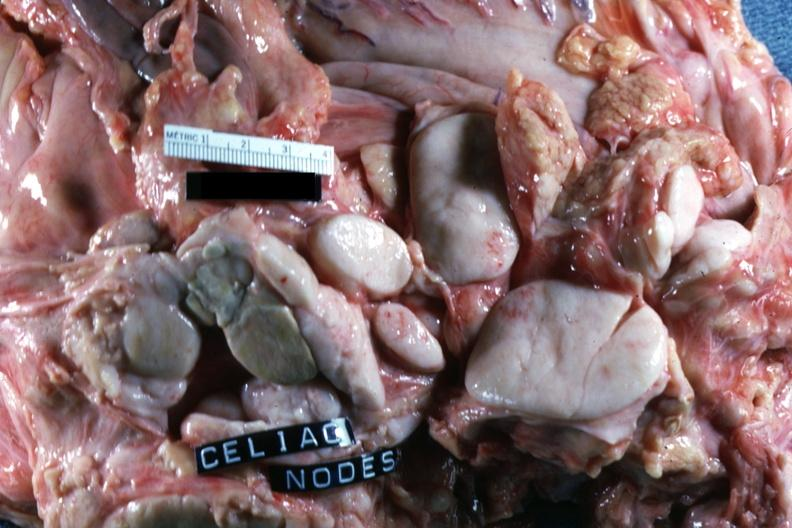what does this image show?
Answer the question using a single word or phrase. Sectioned nodes with ivory white color 